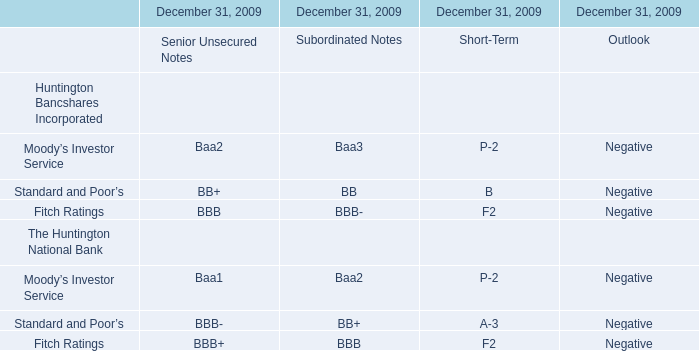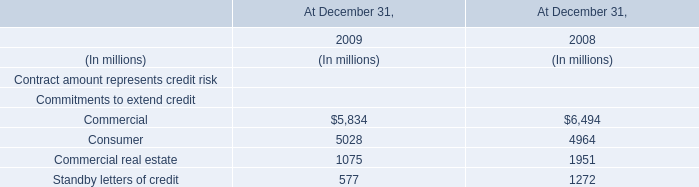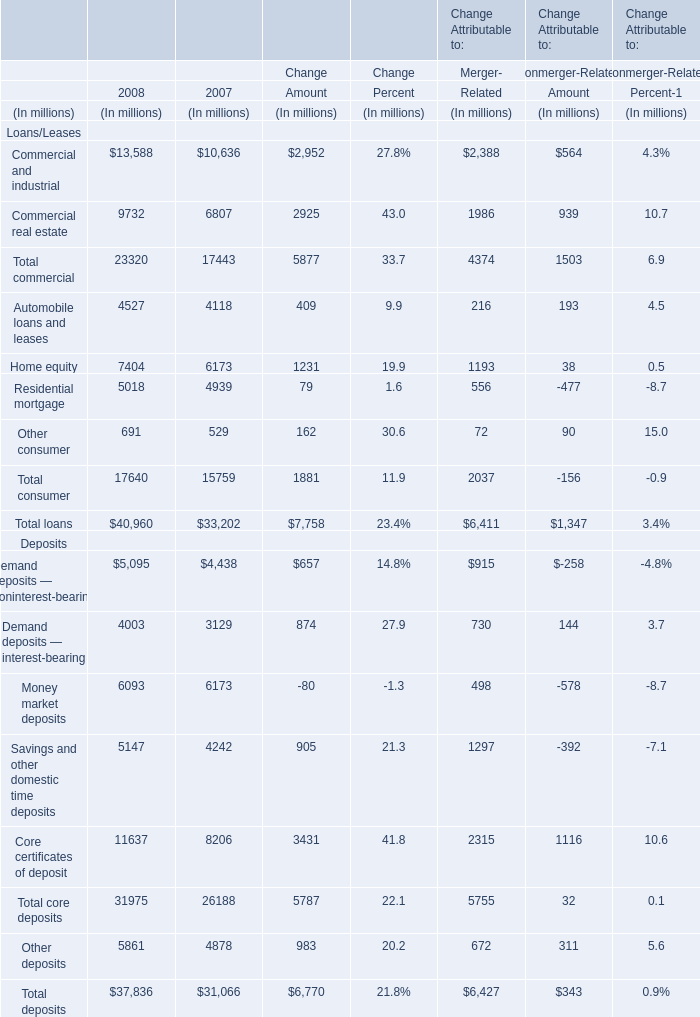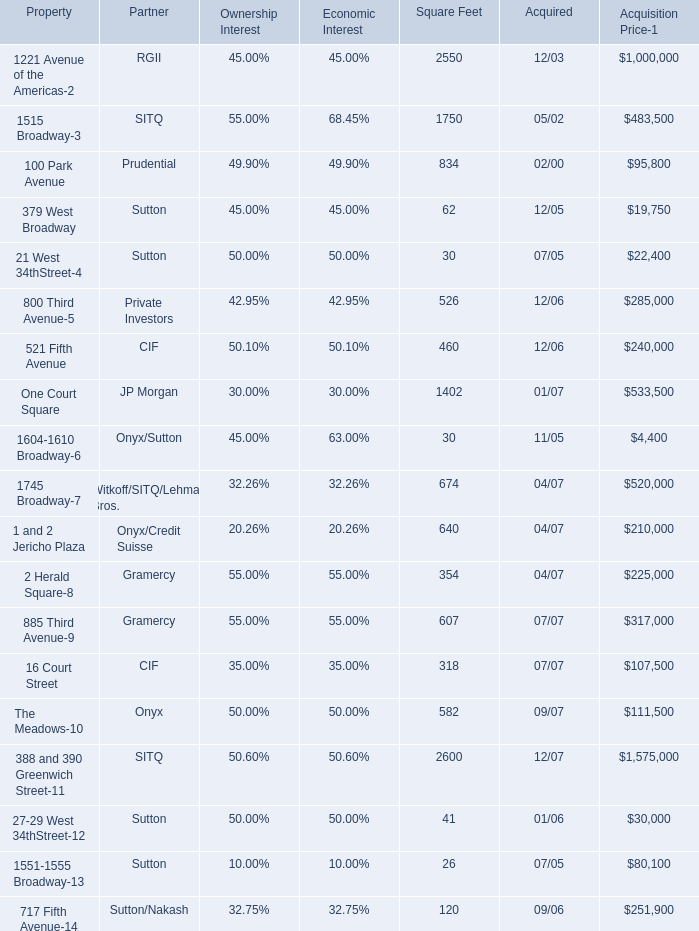what was the total value of the 100 park avenue property based in the acquisition price? 
Computations: ((95800 * 1000) / 49.90%)
Answer: 191983967.93587. 